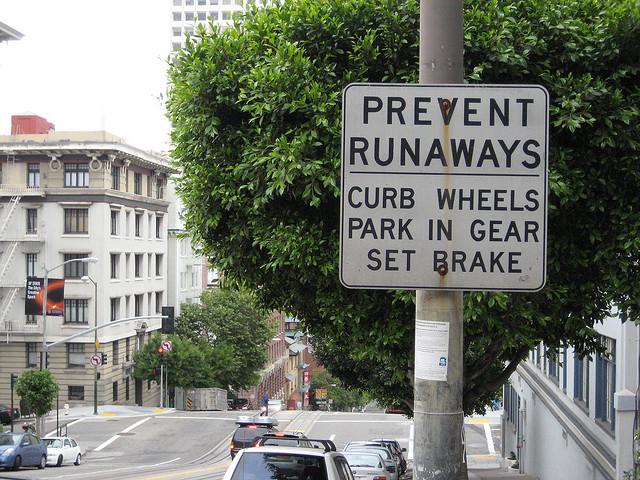What is in the background?
Write a very short answer. Buildings. What does the street sign say?
Keep it brief. Prevent runaways. What number of windows are on the building to the left?
Answer briefly. 30. What shape is the sign?
Be succinct. Square. 